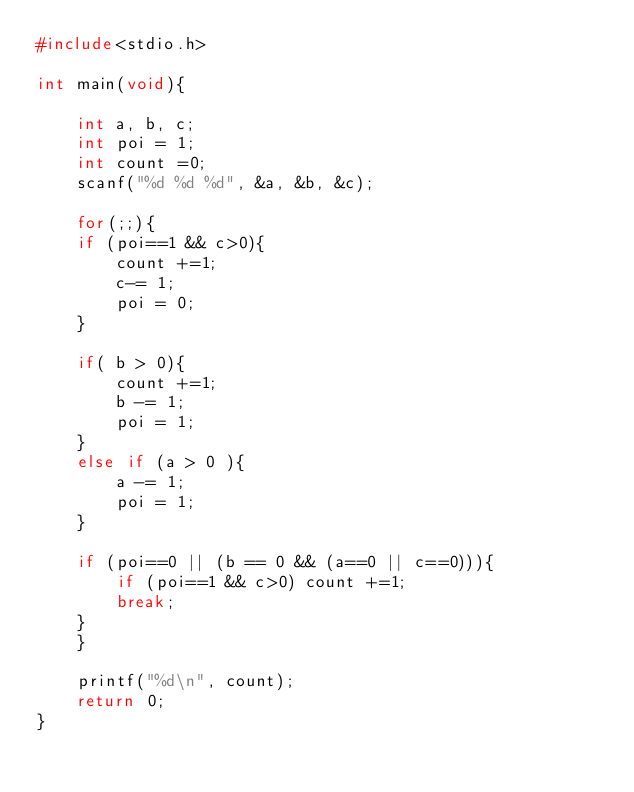<code> <loc_0><loc_0><loc_500><loc_500><_C_>#include<stdio.h>

int main(void){

    int a, b, c;
    int poi = 1;
    int count =0;
    scanf("%d %d %d", &a, &b, &c);
    
    for(;;){
	if (poi==1 && c>0){
	    count +=1;
	    c-= 1;
	    poi = 0;
	}

	if( b > 0){
	    count +=1;
	    b -= 1;
	    poi = 1;
	}
	else if (a > 0 ){
	    a -= 1;
	    poi = 1;
	}

	if (poi==0 || (b == 0 && (a==0 || c==0))){
	    if (poi==1 && c>0) count +=1;
	    break;
	}
    }

    printf("%d\n", count);
    return 0;
}

</code> 